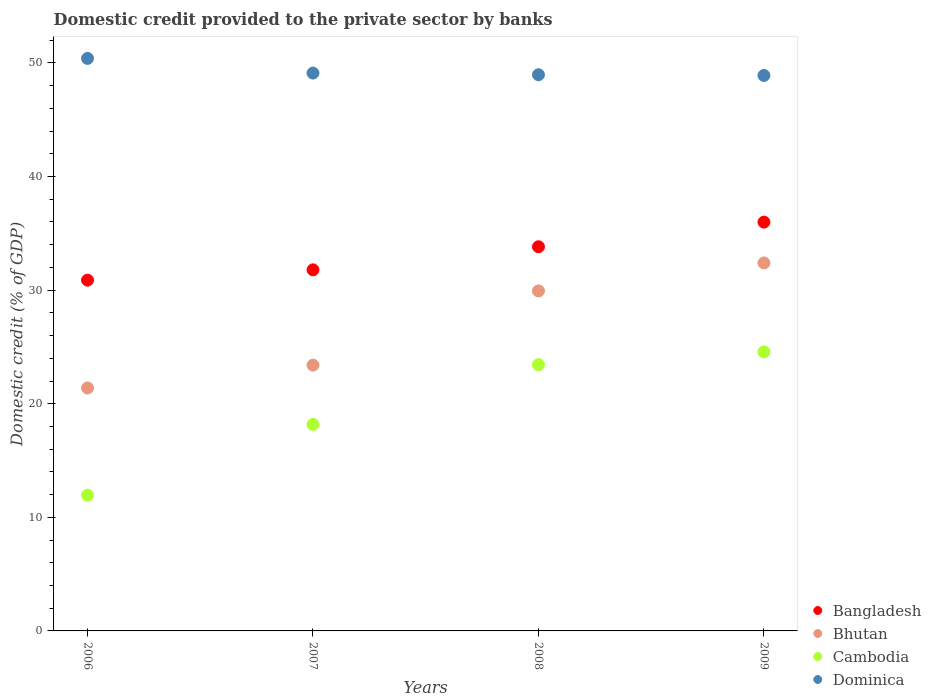What is the domestic credit provided to the private sector by banks in Dominica in 2006?
Offer a very short reply. 50.4. Across all years, what is the maximum domestic credit provided to the private sector by banks in Dominica?
Provide a succinct answer. 50.4. Across all years, what is the minimum domestic credit provided to the private sector by banks in Bangladesh?
Give a very brief answer. 30.88. In which year was the domestic credit provided to the private sector by banks in Bangladesh maximum?
Make the answer very short. 2009. In which year was the domestic credit provided to the private sector by banks in Bangladesh minimum?
Provide a short and direct response. 2006. What is the total domestic credit provided to the private sector by banks in Dominica in the graph?
Offer a very short reply. 197.37. What is the difference between the domestic credit provided to the private sector by banks in Cambodia in 2007 and that in 2008?
Offer a terse response. -5.26. What is the difference between the domestic credit provided to the private sector by banks in Bangladesh in 2007 and the domestic credit provided to the private sector by banks in Bhutan in 2009?
Ensure brevity in your answer.  -0.61. What is the average domestic credit provided to the private sector by banks in Bhutan per year?
Your answer should be compact. 26.78. In the year 2006, what is the difference between the domestic credit provided to the private sector by banks in Dominica and domestic credit provided to the private sector by banks in Cambodia?
Provide a short and direct response. 38.45. In how many years, is the domestic credit provided to the private sector by banks in Dominica greater than 14 %?
Offer a terse response. 4. What is the ratio of the domestic credit provided to the private sector by banks in Bhutan in 2006 to that in 2007?
Keep it short and to the point. 0.91. Is the difference between the domestic credit provided to the private sector by banks in Dominica in 2006 and 2008 greater than the difference between the domestic credit provided to the private sector by banks in Cambodia in 2006 and 2008?
Provide a short and direct response. Yes. What is the difference between the highest and the second highest domestic credit provided to the private sector by banks in Dominica?
Offer a very short reply. 1.29. What is the difference between the highest and the lowest domestic credit provided to the private sector by banks in Dominica?
Your answer should be compact. 1.5. In how many years, is the domestic credit provided to the private sector by banks in Bangladesh greater than the average domestic credit provided to the private sector by banks in Bangladesh taken over all years?
Your answer should be compact. 2. Is the sum of the domestic credit provided to the private sector by banks in Bangladesh in 2006 and 2009 greater than the maximum domestic credit provided to the private sector by banks in Bhutan across all years?
Keep it short and to the point. Yes. Does the domestic credit provided to the private sector by banks in Bangladesh monotonically increase over the years?
Your answer should be compact. Yes. Is the domestic credit provided to the private sector by banks in Cambodia strictly less than the domestic credit provided to the private sector by banks in Dominica over the years?
Give a very brief answer. Yes. How many dotlines are there?
Your answer should be compact. 4. Are the values on the major ticks of Y-axis written in scientific E-notation?
Give a very brief answer. No. Does the graph contain grids?
Provide a short and direct response. No. How many legend labels are there?
Provide a succinct answer. 4. How are the legend labels stacked?
Make the answer very short. Vertical. What is the title of the graph?
Give a very brief answer. Domestic credit provided to the private sector by banks. What is the label or title of the Y-axis?
Provide a short and direct response. Domestic credit (% of GDP). What is the Domestic credit (% of GDP) in Bangladesh in 2006?
Your answer should be very brief. 30.88. What is the Domestic credit (% of GDP) of Bhutan in 2006?
Provide a succinct answer. 21.39. What is the Domestic credit (% of GDP) in Cambodia in 2006?
Provide a succinct answer. 11.95. What is the Domestic credit (% of GDP) in Dominica in 2006?
Your response must be concise. 50.4. What is the Domestic credit (% of GDP) of Bangladesh in 2007?
Make the answer very short. 31.79. What is the Domestic credit (% of GDP) in Bhutan in 2007?
Offer a very short reply. 23.4. What is the Domestic credit (% of GDP) of Cambodia in 2007?
Offer a very short reply. 18.18. What is the Domestic credit (% of GDP) of Dominica in 2007?
Make the answer very short. 49.11. What is the Domestic credit (% of GDP) of Bangladesh in 2008?
Offer a terse response. 33.82. What is the Domestic credit (% of GDP) of Bhutan in 2008?
Offer a terse response. 29.93. What is the Domestic credit (% of GDP) in Cambodia in 2008?
Your answer should be compact. 23.44. What is the Domestic credit (% of GDP) of Dominica in 2008?
Your response must be concise. 48.96. What is the Domestic credit (% of GDP) of Bangladesh in 2009?
Provide a short and direct response. 35.99. What is the Domestic credit (% of GDP) of Bhutan in 2009?
Provide a succinct answer. 32.39. What is the Domestic credit (% of GDP) of Cambodia in 2009?
Provide a short and direct response. 24.57. What is the Domestic credit (% of GDP) of Dominica in 2009?
Offer a very short reply. 48.9. Across all years, what is the maximum Domestic credit (% of GDP) of Bangladesh?
Give a very brief answer. 35.99. Across all years, what is the maximum Domestic credit (% of GDP) in Bhutan?
Provide a succinct answer. 32.39. Across all years, what is the maximum Domestic credit (% of GDP) in Cambodia?
Give a very brief answer. 24.57. Across all years, what is the maximum Domestic credit (% of GDP) of Dominica?
Provide a succinct answer. 50.4. Across all years, what is the minimum Domestic credit (% of GDP) in Bangladesh?
Provide a succinct answer. 30.88. Across all years, what is the minimum Domestic credit (% of GDP) in Bhutan?
Provide a succinct answer. 21.39. Across all years, what is the minimum Domestic credit (% of GDP) in Cambodia?
Your response must be concise. 11.95. Across all years, what is the minimum Domestic credit (% of GDP) in Dominica?
Make the answer very short. 48.9. What is the total Domestic credit (% of GDP) in Bangladesh in the graph?
Offer a very short reply. 132.47. What is the total Domestic credit (% of GDP) in Bhutan in the graph?
Offer a very short reply. 107.11. What is the total Domestic credit (% of GDP) in Cambodia in the graph?
Your response must be concise. 78.14. What is the total Domestic credit (% of GDP) in Dominica in the graph?
Offer a terse response. 197.37. What is the difference between the Domestic credit (% of GDP) of Bangladesh in 2006 and that in 2007?
Give a very brief answer. -0.91. What is the difference between the Domestic credit (% of GDP) of Bhutan in 2006 and that in 2007?
Ensure brevity in your answer.  -2.01. What is the difference between the Domestic credit (% of GDP) of Cambodia in 2006 and that in 2007?
Ensure brevity in your answer.  -6.22. What is the difference between the Domestic credit (% of GDP) of Dominica in 2006 and that in 2007?
Give a very brief answer. 1.29. What is the difference between the Domestic credit (% of GDP) of Bangladesh in 2006 and that in 2008?
Your answer should be compact. -2.94. What is the difference between the Domestic credit (% of GDP) in Bhutan in 2006 and that in 2008?
Provide a succinct answer. -8.55. What is the difference between the Domestic credit (% of GDP) in Cambodia in 2006 and that in 2008?
Make the answer very short. -11.49. What is the difference between the Domestic credit (% of GDP) of Dominica in 2006 and that in 2008?
Your response must be concise. 1.44. What is the difference between the Domestic credit (% of GDP) of Bangladesh in 2006 and that in 2009?
Your response must be concise. -5.11. What is the difference between the Domestic credit (% of GDP) in Bhutan in 2006 and that in 2009?
Make the answer very short. -11.01. What is the difference between the Domestic credit (% of GDP) of Cambodia in 2006 and that in 2009?
Make the answer very short. -12.61. What is the difference between the Domestic credit (% of GDP) of Dominica in 2006 and that in 2009?
Your answer should be compact. 1.5. What is the difference between the Domestic credit (% of GDP) of Bangladesh in 2007 and that in 2008?
Ensure brevity in your answer.  -2.03. What is the difference between the Domestic credit (% of GDP) of Bhutan in 2007 and that in 2008?
Provide a short and direct response. -6.53. What is the difference between the Domestic credit (% of GDP) of Cambodia in 2007 and that in 2008?
Provide a succinct answer. -5.26. What is the difference between the Domestic credit (% of GDP) in Dominica in 2007 and that in 2008?
Make the answer very short. 0.15. What is the difference between the Domestic credit (% of GDP) in Bangladesh in 2007 and that in 2009?
Your response must be concise. -4.2. What is the difference between the Domestic credit (% of GDP) in Bhutan in 2007 and that in 2009?
Provide a short and direct response. -9. What is the difference between the Domestic credit (% of GDP) of Cambodia in 2007 and that in 2009?
Keep it short and to the point. -6.39. What is the difference between the Domestic credit (% of GDP) of Dominica in 2007 and that in 2009?
Your answer should be very brief. 0.21. What is the difference between the Domestic credit (% of GDP) of Bangladesh in 2008 and that in 2009?
Make the answer very short. -2.17. What is the difference between the Domestic credit (% of GDP) of Bhutan in 2008 and that in 2009?
Provide a short and direct response. -2.46. What is the difference between the Domestic credit (% of GDP) in Cambodia in 2008 and that in 2009?
Offer a very short reply. -1.13. What is the difference between the Domestic credit (% of GDP) of Dominica in 2008 and that in 2009?
Offer a very short reply. 0.06. What is the difference between the Domestic credit (% of GDP) of Bangladesh in 2006 and the Domestic credit (% of GDP) of Bhutan in 2007?
Provide a short and direct response. 7.48. What is the difference between the Domestic credit (% of GDP) of Bangladesh in 2006 and the Domestic credit (% of GDP) of Cambodia in 2007?
Provide a succinct answer. 12.7. What is the difference between the Domestic credit (% of GDP) in Bangladesh in 2006 and the Domestic credit (% of GDP) in Dominica in 2007?
Offer a terse response. -18.23. What is the difference between the Domestic credit (% of GDP) in Bhutan in 2006 and the Domestic credit (% of GDP) in Cambodia in 2007?
Your response must be concise. 3.21. What is the difference between the Domestic credit (% of GDP) in Bhutan in 2006 and the Domestic credit (% of GDP) in Dominica in 2007?
Your answer should be compact. -27.72. What is the difference between the Domestic credit (% of GDP) of Cambodia in 2006 and the Domestic credit (% of GDP) of Dominica in 2007?
Ensure brevity in your answer.  -37.15. What is the difference between the Domestic credit (% of GDP) in Bangladesh in 2006 and the Domestic credit (% of GDP) in Bhutan in 2008?
Give a very brief answer. 0.95. What is the difference between the Domestic credit (% of GDP) of Bangladesh in 2006 and the Domestic credit (% of GDP) of Cambodia in 2008?
Offer a terse response. 7.44. What is the difference between the Domestic credit (% of GDP) of Bangladesh in 2006 and the Domestic credit (% of GDP) of Dominica in 2008?
Your answer should be compact. -18.08. What is the difference between the Domestic credit (% of GDP) in Bhutan in 2006 and the Domestic credit (% of GDP) in Cambodia in 2008?
Keep it short and to the point. -2.05. What is the difference between the Domestic credit (% of GDP) in Bhutan in 2006 and the Domestic credit (% of GDP) in Dominica in 2008?
Your answer should be very brief. -27.58. What is the difference between the Domestic credit (% of GDP) of Cambodia in 2006 and the Domestic credit (% of GDP) of Dominica in 2008?
Provide a succinct answer. -37.01. What is the difference between the Domestic credit (% of GDP) of Bangladesh in 2006 and the Domestic credit (% of GDP) of Bhutan in 2009?
Offer a very short reply. -1.52. What is the difference between the Domestic credit (% of GDP) in Bangladesh in 2006 and the Domestic credit (% of GDP) in Cambodia in 2009?
Keep it short and to the point. 6.31. What is the difference between the Domestic credit (% of GDP) in Bangladesh in 2006 and the Domestic credit (% of GDP) in Dominica in 2009?
Offer a very short reply. -18.02. What is the difference between the Domestic credit (% of GDP) in Bhutan in 2006 and the Domestic credit (% of GDP) in Cambodia in 2009?
Offer a terse response. -3.18. What is the difference between the Domestic credit (% of GDP) of Bhutan in 2006 and the Domestic credit (% of GDP) of Dominica in 2009?
Ensure brevity in your answer.  -27.51. What is the difference between the Domestic credit (% of GDP) in Cambodia in 2006 and the Domestic credit (% of GDP) in Dominica in 2009?
Provide a short and direct response. -36.94. What is the difference between the Domestic credit (% of GDP) of Bangladesh in 2007 and the Domestic credit (% of GDP) of Bhutan in 2008?
Give a very brief answer. 1.86. What is the difference between the Domestic credit (% of GDP) of Bangladesh in 2007 and the Domestic credit (% of GDP) of Cambodia in 2008?
Ensure brevity in your answer.  8.35. What is the difference between the Domestic credit (% of GDP) of Bangladesh in 2007 and the Domestic credit (% of GDP) of Dominica in 2008?
Ensure brevity in your answer.  -17.17. What is the difference between the Domestic credit (% of GDP) in Bhutan in 2007 and the Domestic credit (% of GDP) in Cambodia in 2008?
Your response must be concise. -0.04. What is the difference between the Domestic credit (% of GDP) in Bhutan in 2007 and the Domestic credit (% of GDP) in Dominica in 2008?
Offer a terse response. -25.56. What is the difference between the Domestic credit (% of GDP) in Cambodia in 2007 and the Domestic credit (% of GDP) in Dominica in 2008?
Offer a very short reply. -30.78. What is the difference between the Domestic credit (% of GDP) in Bangladesh in 2007 and the Domestic credit (% of GDP) in Bhutan in 2009?
Ensure brevity in your answer.  -0.61. What is the difference between the Domestic credit (% of GDP) of Bangladesh in 2007 and the Domestic credit (% of GDP) of Cambodia in 2009?
Offer a terse response. 7.22. What is the difference between the Domestic credit (% of GDP) in Bangladesh in 2007 and the Domestic credit (% of GDP) in Dominica in 2009?
Your response must be concise. -17.11. What is the difference between the Domestic credit (% of GDP) in Bhutan in 2007 and the Domestic credit (% of GDP) in Cambodia in 2009?
Give a very brief answer. -1.17. What is the difference between the Domestic credit (% of GDP) of Bhutan in 2007 and the Domestic credit (% of GDP) of Dominica in 2009?
Give a very brief answer. -25.5. What is the difference between the Domestic credit (% of GDP) of Cambodia in 2007 and the Domestic credit (% of GDP) of Dominica in 2009?
Give a very brief answer. -30.72. What is the difference between the Domestic credit (% of GDP) of Bangladesh in 2008 and the Domestic credit (% of GDP) of Bhutan in 2009?
Your response must be concise. 1.42. What is the difference between the Domestic credit (% of GDP) of Bangladesh in 2008 and the Domestic credit (% of GDP) of Cambodia in 2009?
Keep it short and to the point. 9.25. What is the difference between the Domestic credit (% of GDP) of Bangladesh in 2008 and the Domestic credit (% of GDP) of Dominica in 2009?
Make the answer very short. -15.08. What is the difference between the Domestic credit (% of GDP) of Bhutan in 2008 and the Domestic credit (% of GDP) of Cambodia in 2009?
Offer a very short reply. 5.36. What is the difference between the Domestic credit (% of GDP) in Bhutan in 2008 and the Domestic credit (% of GDP) in Dominica in 2009?
Keep it short and to the point. -18.97. What is the difference between the Domestic credit (% of GDP) in Cambodia in 2008 and the Domestic credit (% of GDP) in Dominica in 2009?
Make the answer very short. -25.46. What is the average Domestic credit (% of GDP) of Bangladesh per year?
Your response must be concise. 33.12. What is the average Domestic credit (% of GDP) of Bhutan per year?
Make the answer very short. 26.78. What is the average Domestic credit (% of GDP) of Cambodia per year?
Your response must be concise. 19.53. What is the average Domestic credit (% of GDP) of Dominica per year?
Provide a succinct answer. 49.34. In the year 2006, what is the difference between the Domestic credit (% of GDP) of Bangladesh and Domestic credit (% of GDP) of Bhutan?
Offer a very short reply. 9.49. In the year 2006, what is the difference between the Domestic credit (% of GDP) in Bangladesh and Domestic credit (% of GDP) in Cambodia?
Your answer should be very brief. 18.92. In the year 2006, what is the difference between the Domestic credit (% of GDP) in Bangladesh and Domestic credit (% of GDP) in Dominica?
Give a very brief answer. -19.52. In the year 2006, what is the difference between the Domestic credit (% of GDP) of Bhutan and Domestic credit (% of GDP) of Cambodia?
Keep it short and to the point. 9.43. In the year 2006, what is the difference between the Domestic credit (% of GDP) in Bhutan and Domestic credit (% of GDP) in Dominica?
Your response must be concise. -29.01. In the year 2006, what is the difference between the Domestic credit (% of GDP) in Cambodia and Domestic credit (% of GDP) in Dominica?
Keep it short and to the point. -38.45. In the year 2007, what is the difference between the Domestic credit (% of GDP) in Bangladesh and Domestic credit (% of GDP) in Bhutan?
Give a very brief answer. 8.39. In the year 2007, what is the difference between the Domestic credit (% of GDP) of Bangladesh and Domestic credit (% of GDP) of Cambodia?
Make the answer very short. 13.61. In the year 2007, what is the difference between the Domestic credit (% of GDP) in Bangladesh and Domestic credit (% of GDP) in Dominica?
Provide a succinct answer. -17.32. In the year 2007, what is the difference between the Domestic credit (% of GDP) of Bhutan and Domestic credit (% of GDP) of Cambodia?
Keep it short and to the point. 5.22. In the year 2007, what is the difference between the Domestic credit (% of GDP) in Bhutan and Domestic credit (% of GDP) in Dominica?
Keep it short and to the point. -25.71. In the year 2007, what is the difference between the Domestic credit (% of GDP) in Cambodia and Domestic credit (% of GDP) in Dominica?
Offer a terse response. -30.93. In the year 2008, what is the difference between the Domestic credit (% of GDP) in Bangladesh and Domestic credit (% of GDP) in Bhutan?
Make the answer very short. 3.89. In the year 2008, what is the difference between the Domestic credit (% of GDP) in Bangladesh and Domestic credit (% of GDP) in Cambodia?
Give a very brief answer. 10.38. In the year 2008, what is the difference between the Domestic credit (% of GDP) of Bangladesh and Domestic credit (% of GDP) of Dominica?
Provide a short and direct response. -15.14. In the year 2008, what is the difference between the Domestic credit (% of GDP) in Bhutan and Domestic credit (% of GDP) in Cambodia?
Your answer should be very brief. 6.49. In the year 2008, what is the difference between the Domestic credit (% of GDP) in Bhutan and Domestic credit (% of GDP) in Dominica?
Ensure brevity in your answer.  -19.03. In the year 2008, what is the difference between the Domestic credit (% of GDP) of Cambodia and Domestic credit (% of GDP) of Dominica?
Make the answer very short. -25.52. In the year 2009, what is the difference between the Domestic credit (% of GDP) of Bangladesh and Domestic credit (% of GDP) of Bhutan?
Your answer should be compact. 3.59. In the year 2009, what is the difference between the Domestic credit (% of GDP) of Bangladesh and Domestic credit (% of GDP) of Cambodia?
Provide a short and direct response. 11.42. In the year 2009, what is the difference between the Domestic credit (% of GDP) in Bangladesh and Domestic credit (% of GDP) in Dominica?
Keep it short and to the point. -12.91. In the year 2009, what is the difference between the Domestic credit (% of GDP) of Bhutan and Domestic credit (% of GDP) of Cambodia?
Offer a very short reply. 7.83. In the year 2009, what is the difference between the Domestic credit (% of GDP) of Bhutan and Domestic credit (% of GDP) of Dominica?
Offer a terse response. -16.5. In the year 2009, what is the difference between the Domestic credit (% of GDP) in Cambodia and Domestic credit (% of GDP) in Dominica?
Your answer should be compact. -24.33. What is the ratio of the Domestic credit (% of GDP) in Bangladesh in 2006 to that in 2007?
Your response must be concise. 0.97. What is the ratio of the Domestic credit (% of GDP) in Bhutan in 2006 to that in 2007?
Offer a terse response. 0.91. What is the ratio of the Domestic credit (% of GDP) of Cambodia in 2006 to that in 2007?
Offer a very short reply. 0.66. What is the ratio of the Domestic credit (% of GDP) of Dominica in 2006 to that in 2007?
Give a very brief answer. 1.03. What is the ratio of the Domestic credit (% of GDP) of Bangladesh in 2006 to that in 2008?
Your response must be concise. 0.91. What is the ratio of the Domestic credit (% of GDP) in Bhutan in 2006 to that in 2008?
Offer a terse response. 0.71. What is the ratio of the Domestic credit (% of GDP) in Cambodia in 2006 to that in 2008?
Make the answer very short. 0.51. What is the ratio of the Domestic credit (% of GDP) in Dominica in 2006 to that in 2008?
Ensure brevity in your answer.  1.03. What is the ratio of the Domestic credit (% of GDP) in Bangladesh in 2006 to that in 2009?
Offer a terse response. 0.86. What is the ratio of the Domestic credit (% of GDP) in Bhutan in 2006 to that in 2009?
Provide a succinct answer. 0.66. What is the ratio of the Domestic credit (% of GDP) of Cambodia in 2006 to that in 2009?
Offer a terse response. 0.49. What is the ratio of the Domestic credit (% of GDP) of Dominica in 2006 to that in 2009?
Your answer should be very brief. 1.03. What is the ratio of the Domestic credit (% of GDP) in Bangladesh in 2007 to that in 2008?
Give a very brief answer. 0.94. What is the ratio of the Domestic credit (% of GDP) in Bhutan in 2007 to that in 2008?
Offer a very short reply. 0.78. What is the ratio of the Domestic credit (% of GDP) in Cambodia in 2007 to that in 2008?
Provide a short and direct response. 0.78. What is the ratio of the Domestic credit (% of GDP) of Bangladesh in 2007 to that in 2009?
Ensure brevity in your answer.  0.88. What is the ratio of the Domestic credit (% of GDP) of Bhutan in 2007 to that in 2009?
Provide a short and direct response. 0.72. What is the ratio of the Domestic credit (% of GDP) of Cambodia in 2007 to that in 2009?
Provide a succinct answer. 0.74. What is the ratio of the Domestic credit (% of GDP) of Bangladesh in 2008 to that in 2009?
Offer a very short reply. 0.94. What is the ratio of the Domestic credit (% of GDP) in Bhutan in 2008 to that in 2009?
Provide a short and direct response. 0.92. What is the ratio of the Domestic credit (% of GDP) of Cambodia in 2008 to that in 2009?
Offer a very short reply. 0.95. What is the ratio of the Domestic credit (% of GDP) in Dominica in 2008 to that in 2009?
Offer a terse response. 1. What is the difference between the highest and the second highest Domestic credit (% of GDP) of Bangladesh?
Ensure brevity in your answer.  2.17. What is the difference between the highest and the second highest Domestic credit (% of GDP) of Bhutan?
Your answer should be compact. 2.46. What is the difference between the highest and the second highest Domestic credit (% of GDP) of Cambodia?
Offer a terse response. 1.13. What is the difference between the highest and the second highest Domestic credit (% of GDP) of Dominica?
Ensure brevity in your answer.  1.29. What is the difference between the highest and the lowest Domestic credit (% of GDP) in Bangladesh?
Provide a short and direct response. 5.11. What is the difference between the highest and the lowest Domestic credit (% of GDP) in Bhutan?
Offer a very short reply. 11.01. What is the difference between the highest and the lowest Domestic credit (% of GDP) in Cambodia?
Your response must be concise. 12.61. What is the difference between the highest and the lowest Domestic credit (% of GDP) of Dominica?
Offer a terse response. 1.5. 